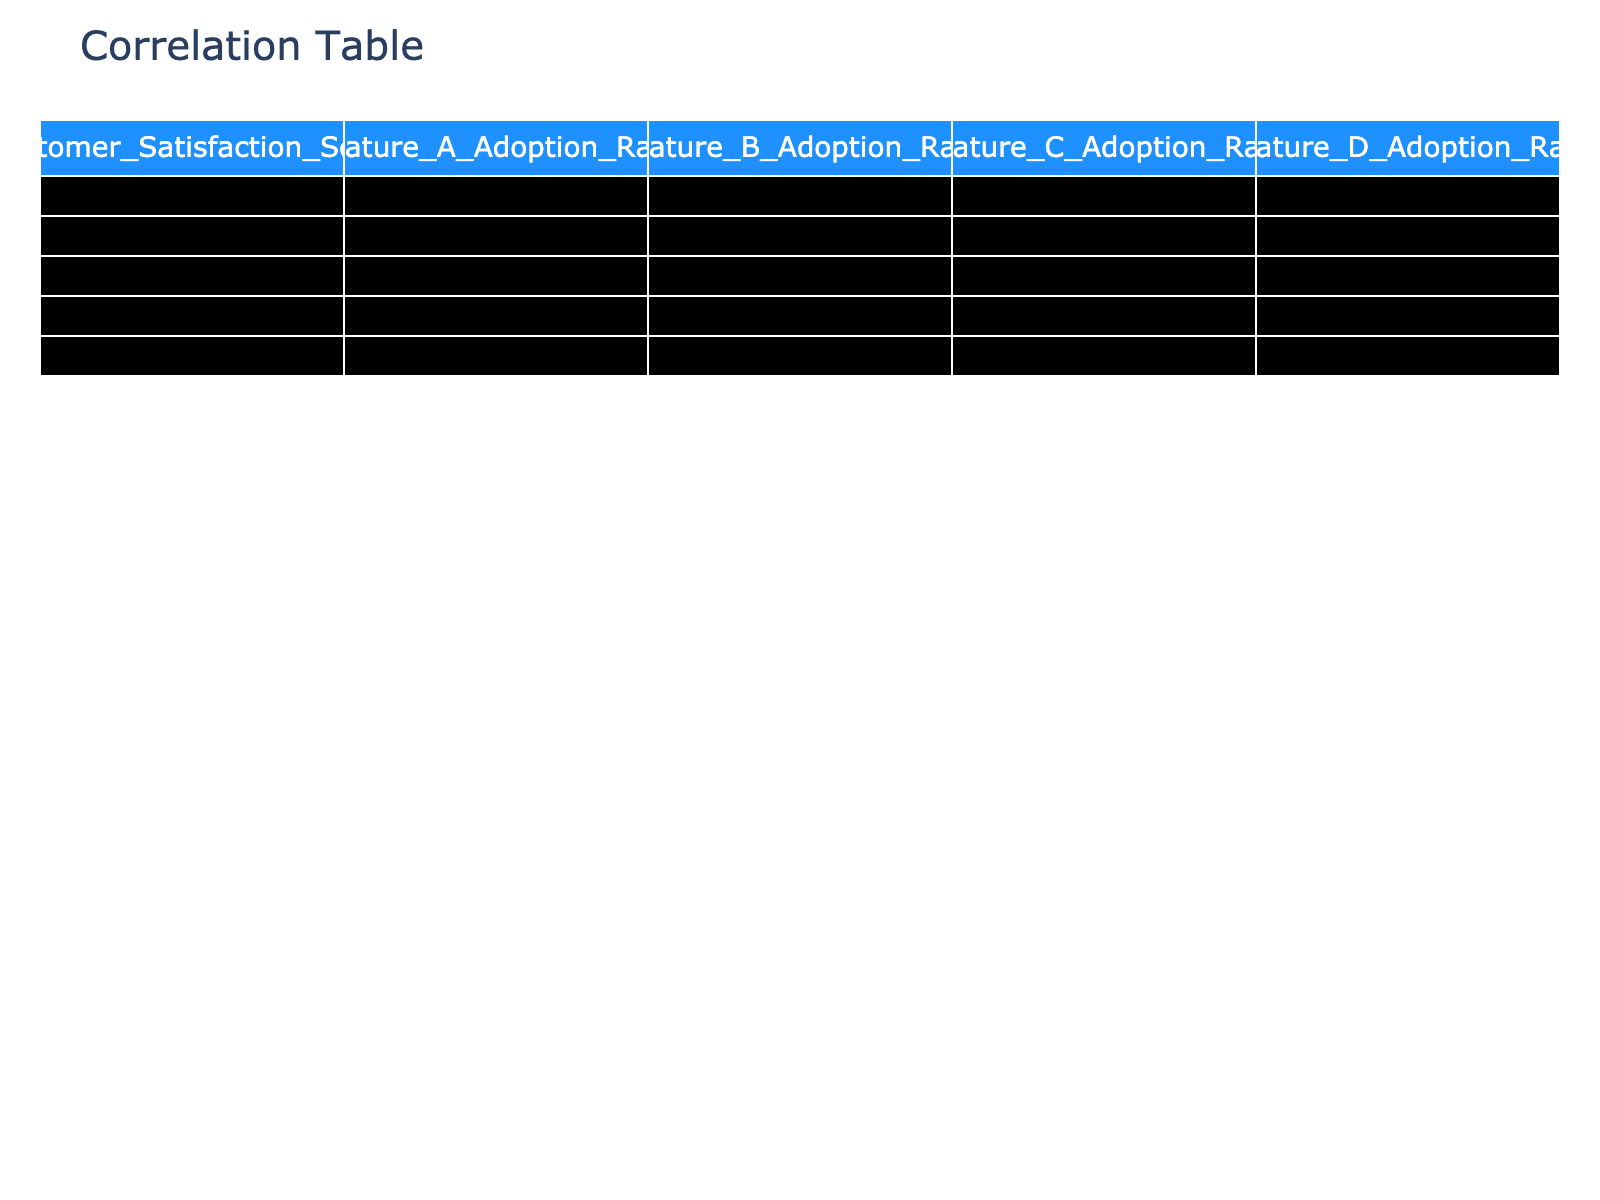What is the correlation between Customer Satisfaction Score and Feature A Adoption Rate? The correlation value in the table for Customer Satisfaction Score and Feature A Adoption Rate is 0.83. This means there is a strong positive relationship, indicating that higher satisfaction scores are associated with higher adoption rates of Feature A.
Answer: 0.83 Which feature has the lowest adoption rate? Looking at the table, the lowest feature adoption rate is for Feature B, which has a maximum value of 0.65 for its correlation with Customer Satisfaction Score.
Answer: Feature B What is the correlation between Customer Satisfaction Score and Feature C Adoption Rate? The correlation value for Customer Satisfaction Score and Feature C Adoption Rate is 0.74, indicating a strong positive correlation between these two variables.
Answer: 0.74 Is there a strong correlation between Feature D Adoption Rate and Customer Satisfaction Score? Yes, the correlation value is 0.90, which indicates a very strong positive correlation between Feature D Adoption Rate and Customer Satisfaction Score, meaning as one increases, the other tends to increase as well.
Answer: Yes What is the average correlation value of all feature adoption rates with Customer Satisfaction Score? The correlation values are 0.83 (Feature A), 0.66 (Feature B), 0.74 (Feature C), and 0.90 (Feature D). To find the average, sum these values (0.83 + 0.66 + 0.74 + 0.90 = 3.13) and divide by 4, yielding an average of approximately 0.783.
Answer: 0.78 Which feature’s adoption rate is least correlated with the Customer Satisfaction Score? The correlation values for Feature A, B, C, and D are 0.83, 0.66, 0.74, and 0.90 respectively. The lowest correlation value is for Feature B at 0.66.
Answer: Feature B What is the difference in correlation between Feature A Adoption Rate and Feature D Adoption Rate with Customer Satisfaction Score? The correlation for Feature A is 0.83, while for Feature D it is 0.90. To find the difference, subtract the lower correlation from the higher (0.90 - 0.83 = 0.07).
Answer: 0.07 Is the correlation between Feature A and Feature C Adoption Rate higher than 0.70? Looking at the table, the correlation between Feature A and Feature C is 0.63, which is below 0.70. Therefore, the statement is false.
Answer: No What can we infer about the relationship between Feature D Adoption Rate and customer satisfaction based on the correlation value? The correlation value of 0.90 implies a very strong positive relationship, suggesting that as customers adopt Feature D to a greater extent, their satisfaction likely increases as well.
Answer: Very strong positive relationship 